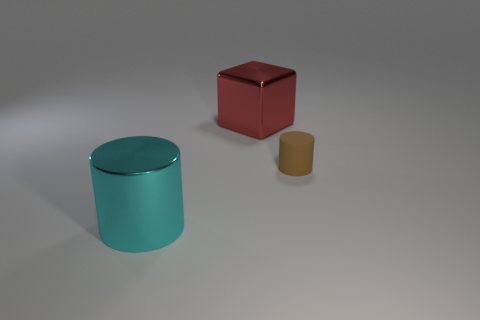Is there anything else that is made of the same material as the small brown thing?
Your answer should be very brief. No. The metallic thing that is the same size as the shiny cylinder is what color?
Offer a very short reply. Red. What color is the block?
Keep it short and to the point. Red. There is a cylinder right of the red object; what is it made of?
Your answer should be very brief. Rubber. What is the size of the other cyan metallic object that is the same shape as the small object?
Offer a very short reply. Large. Are there fewer tiny brown rubber things on the left side of the large shiny cylinder than brown matte things?
Give a very brief answer. Yes. Are any small brown cylinders visible?
Provide a succinct answer. Yes. What is the color of the small object that is the same shape as the big cyan metal thing?
Give a very brief answer. Brown. Is the color of the thing that is to the right of the red block the same as the large shiny block?
Offer a terse response. No. Do the matte thing and the red shiny block have the same size?
Your answer should be compact. No. 